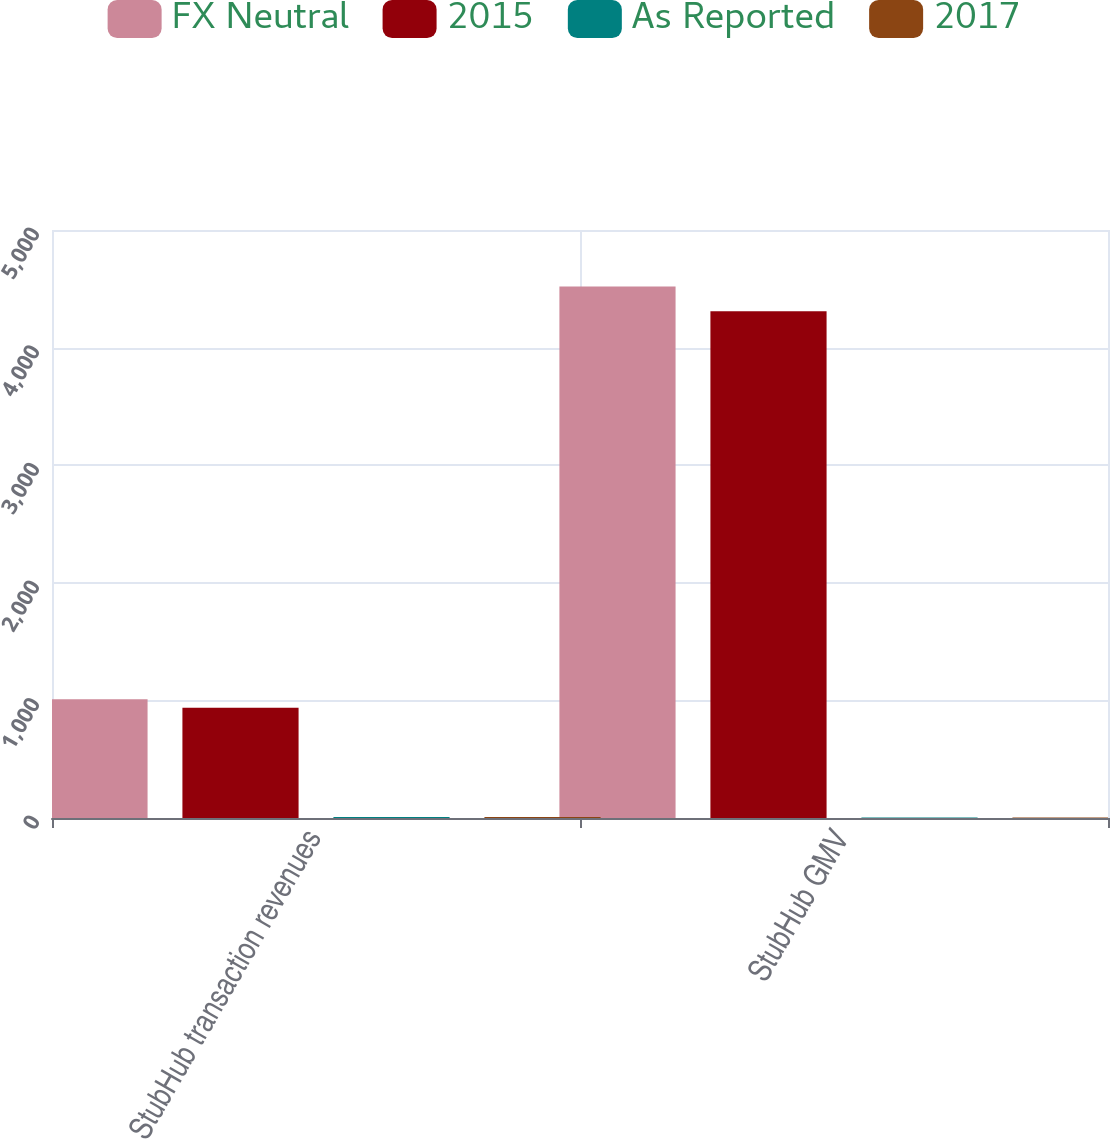Convert chart. <chart><loc_0><loc_0><loc_500><loc_500><stacked_bar_chart><ecel><fcel>StubHub transaction revenues<fcel>StubHub GMV<nl><fcel>FX Neutral<fcel>1010<fcel>4520<nl><fcel>2015<fcel>937<fcel>4310<nl><fcel>As Reported<fcel>8<fcel>5<nl><fcel>2017<fcel>8<fcel>5<nl></chart> 